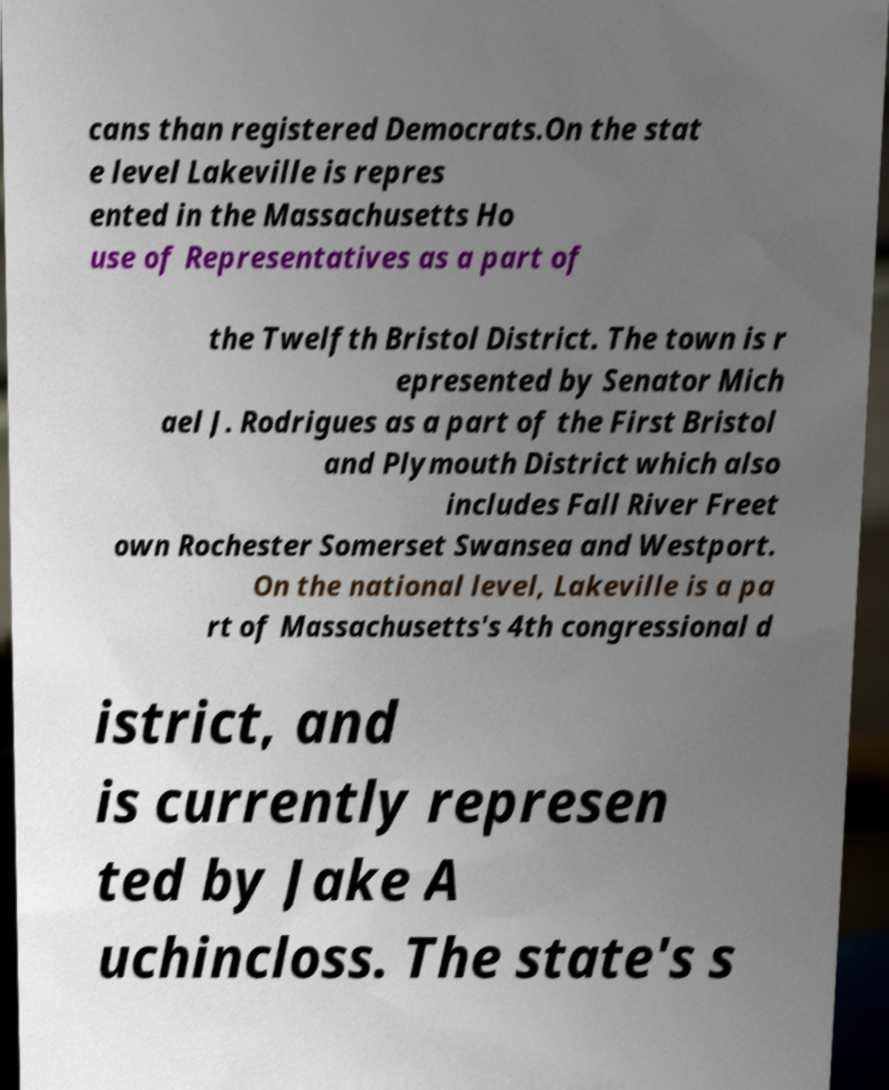There's text embedded in this image that I need extracted. Can you transcribe it verbatim? cans than registered Democrats.On the stat e level Lakeville is repres ented in the Massachusetts Ho use of Representatives as a part of the Twelfth Bristol District. The town is r epresented by Senator Mich ael J. Rodrigues as a part of the First Bristol and Plymouth District which also includes Fall River Freet own Rochester Somerset Swansea and Westport. On the national level, Lakeville is a pa rt of Massachusetts's 4th congressional d istrict, and is currently represen ted by Jake A uchincloss. The state's s 